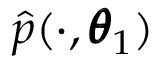<formula> <loc_0><loc_0><loc_500><loc_500>\hat { p } ( \cdot , \pm b \theta _ { 1 } )</formula> 